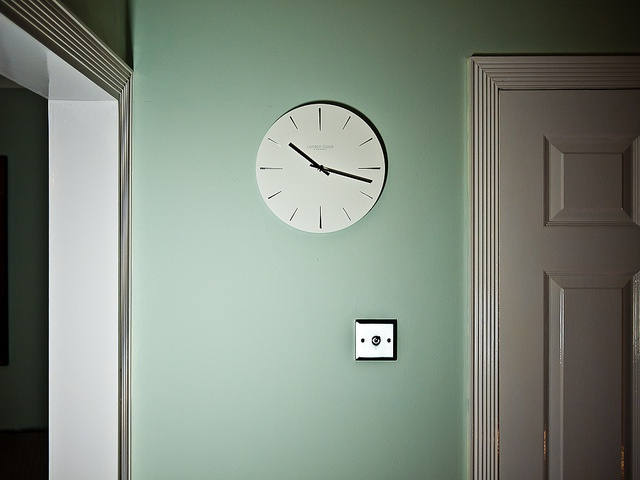Describe the objects in this image and their specific colors. I can see a clock in black, lightgray, and darkgray tones in this image. 